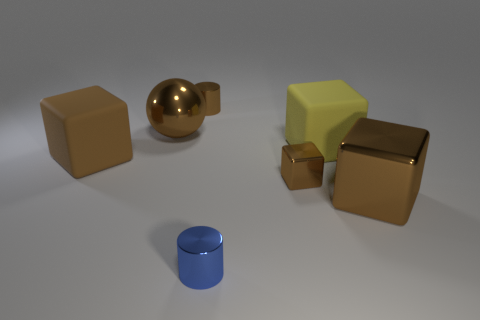Subtract all brown blocks. How many were subtracted if there are1brown blocks left? 2 Subtract all large blocks. How many blocks are left? 1 Subtract all cylinders. How many objects are left? 5 Subtract all yellow cubes. How many cubes are left? 3 Subtract 1 cylinders. How many cylinders are left? 1 Subtract all purple cubes. How many brown cylinders are left? 1 Subtract all small metallic cubes. Subtract all blue objects. How many objects are left? 5 Add 4 large rubber things. How many large rubber things are left? 6 Add 2 brown rubber cubes. How many brown rubber cubes exist? 3 Add 2 small purple metallic objects. How many objects exist? 9 